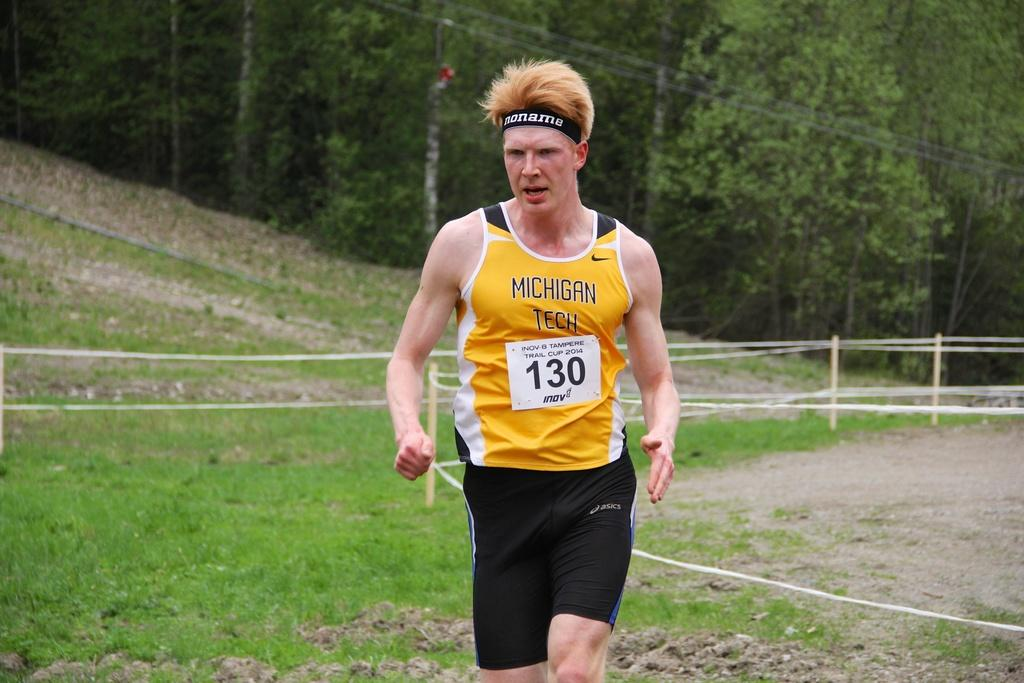Provide a one-sentence caption for the provided image. A runner from Michigan Tech donning the number 130. 